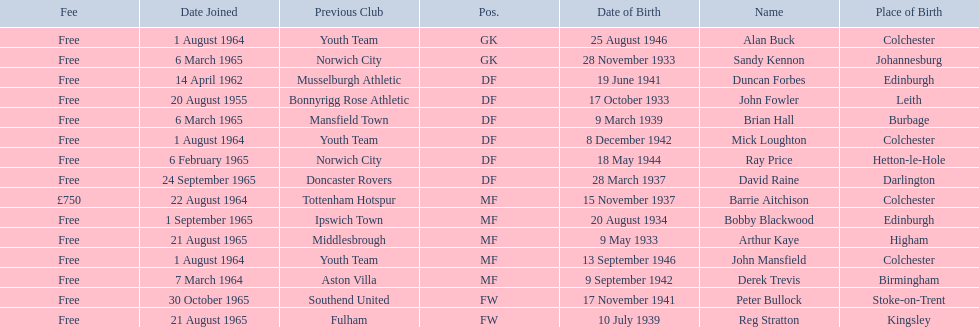When did each player join? 1 August 1964, 6 March 1965, 14 April 1962, 20 August 1955, 6 March 1965, 1 August 1964, 6 February 1965, 24 September 1965, 22 August 1964, 1 September 1965, 21 August 1965, 1 August 1964, 7 March 1964, 30 October 1965, 21 August 1965. And of those, which is the earliest join date? 20 August 1955. 